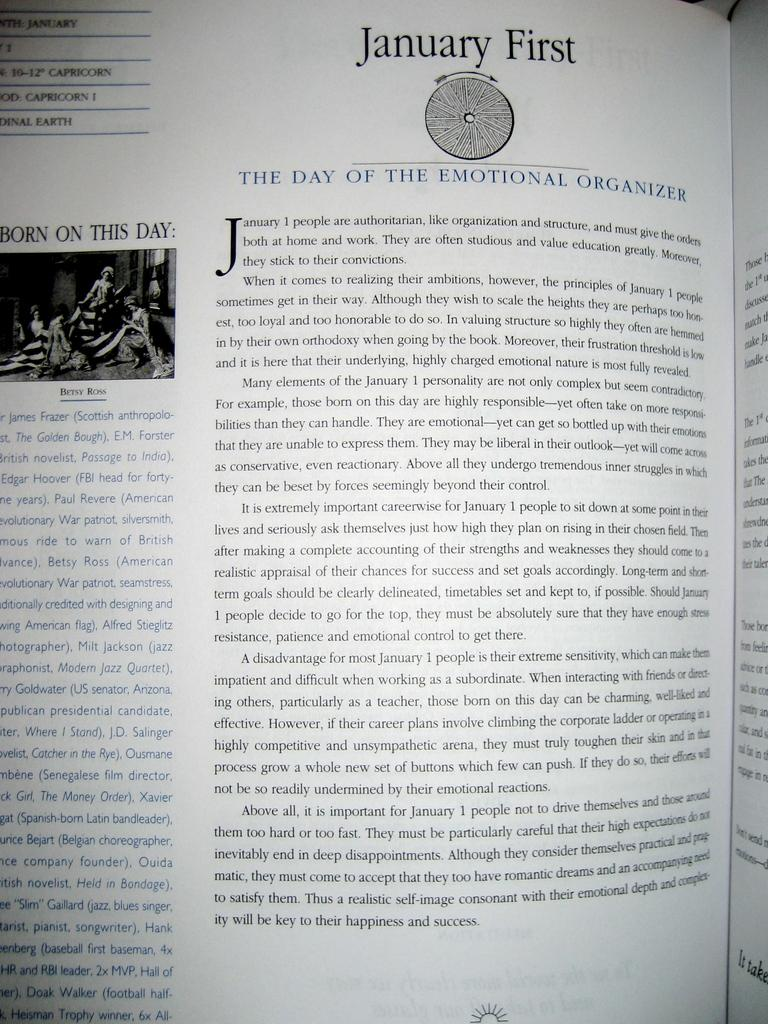<image>
Share a concise interpretation of the image provided. A book page tells us that January first is the day of the emotional organizer. 